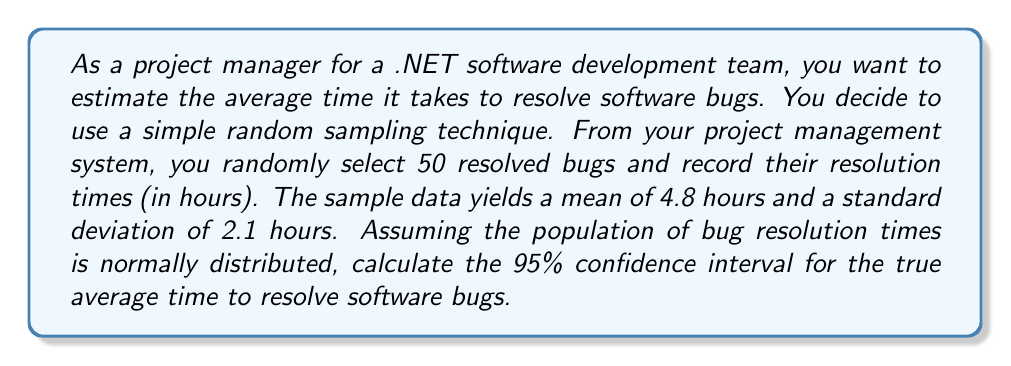Can you solve this math problem? To calculate the confidence interval, we'll use the formula:

$$ \text{CI} = \bar{x} \pm t_{\alpha/2, n-1} \cdot \frac{s}{\sqrt{n}} $$

Where:
- $\bar{x}$ is the sample mean (4.8 hours)
- $s$ is the sample standard deviation (2.1 hours)
- $n$ is the sample size (50)
- $t_{\alpha/2, n-1}$ is the t-value for a 95% confidence level with 49 degrees of freedom

Steps:
1. Find the t-value:
   For a 95% confidence level and 49 degrees of freedom, $t_{\alpha/2, n-1} = t_{0.025, 49} \approx 2.01$ (from t-distribution table)

2. Calculate the margin of error:
   $$ \text{Margin of Error} = t_{\alpha/2, n-1} \cdot \frac{s}{\sqrt{n}} = 2.01 \cdot \frac{2.1}{\sqrt{50}} \approx 0.5982 $$

3. Calculate the confidence interval:
   $$ \text{CI} = 4.8 \pm 0.5982 $$

4. Express the result as an interval:
   $$ \text{CI} = (4.8 - 0.5982, 4.8 + 0.5982) = (4.2018, 5.3982) $$
Answer: The 95% confidence interval for the true average time to resolve software bugs is approximately (4.20, 5.40) hours. 